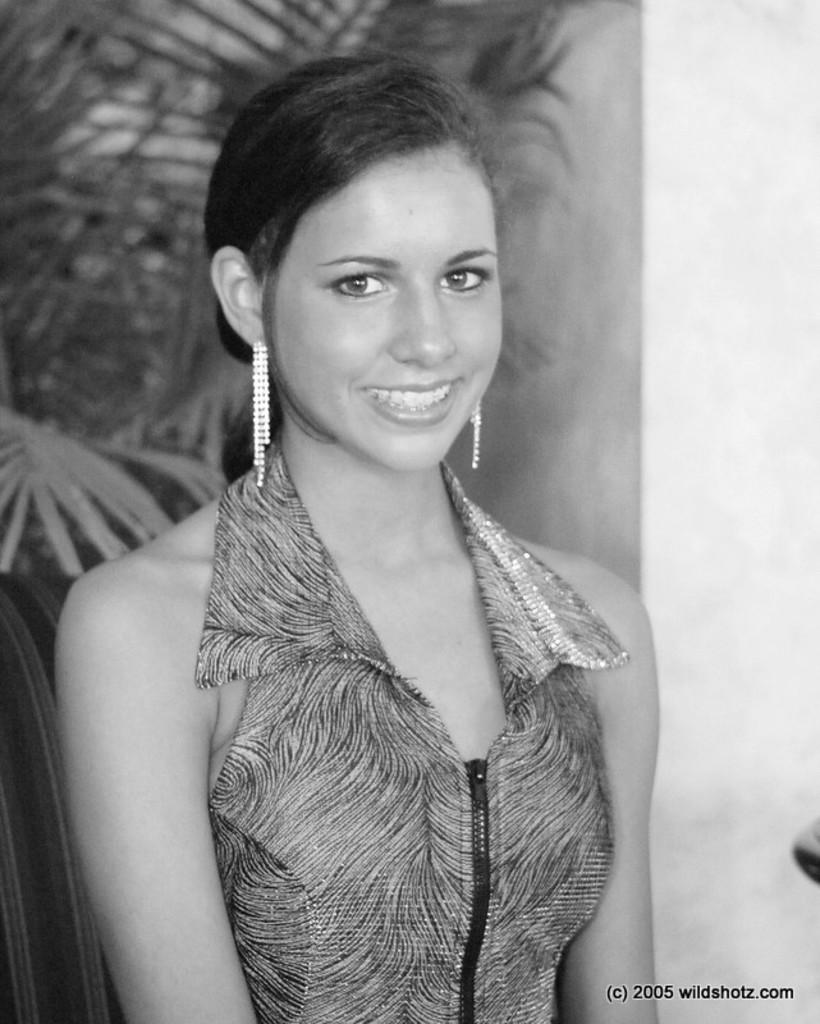Who or what is present in the image? There is a person in the image. What is the person doing or expressing? The person is smiling. What can be seen in the background of the image? There are trees behind the person. What type of structure is visible in the image? There is a wall in the image. What is written or displayed at the bottom of the image? There is some text at the bottom of the image. What type of vegetable is being harvested in the plantation behind the person? There is no plantation or vegetable present in the image; it only features a person, trees, a wall, and some text. 